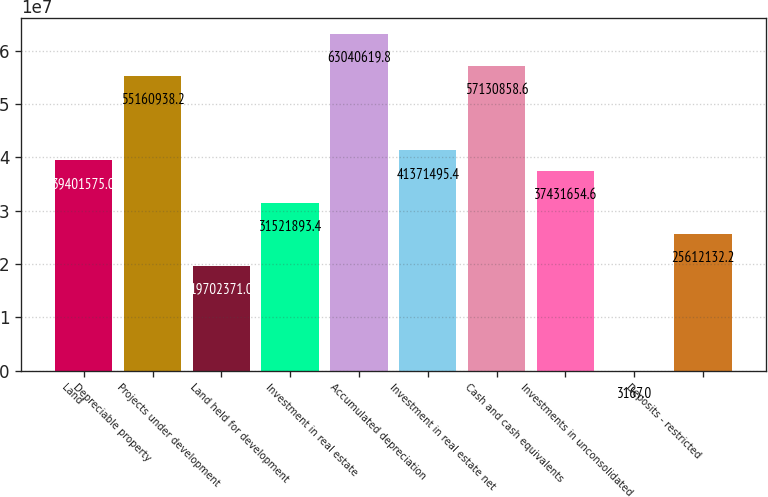<chart> <loc_0><loc_0><loc_500><loc_500><bar_chart><fcel>Land<fcel>Depreciable property<fcel>Projects under development<fcel>Land held for development<fcel>Investment in real estate<fcel>Accumulated depreciation<fcel>Investment in real estate net<fcel>Cash and cash equivalents<fcel>Investments in unconsolidated<fcel>Deposits - restricted<nl><fcel>3.94016e+07<fcel>5.51609e+07<fcel>1.97024e+07<fcel>3.15219e+07<fcel>6.30406e+07<fcel>4.13715e+07<fcel>5.71309e+07<fcel>3.74317e+07<fcel>3167<fcel>2.56121e+07<nl></chart> 